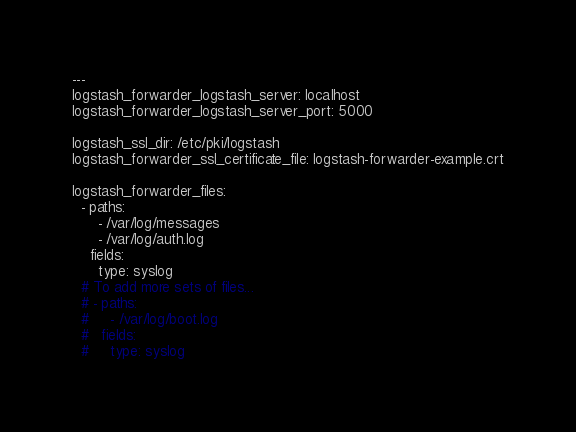Convert code to text. <code><loc_0><loc_0><loc_500><loc_500><_YAML_>---
logstash_forwarder_logstash_server: localhost
logstash_forwarder_logstash_server_port: 5000

logstash_ssl_dir: /etc/pki/logstash
logstash_forwarder_ssl_certificate_file: logstash-forwarder-example.crt

logstash_forwarder_files:
  - paths:
      - /var/log/messages
      - /var/log/auth.log
    fields:
      type: syslog
  # To add more sets of files...
  # - paths:
  #     - /var/log/boot.log
  #   fields:
  #     type: syslog
</code> 